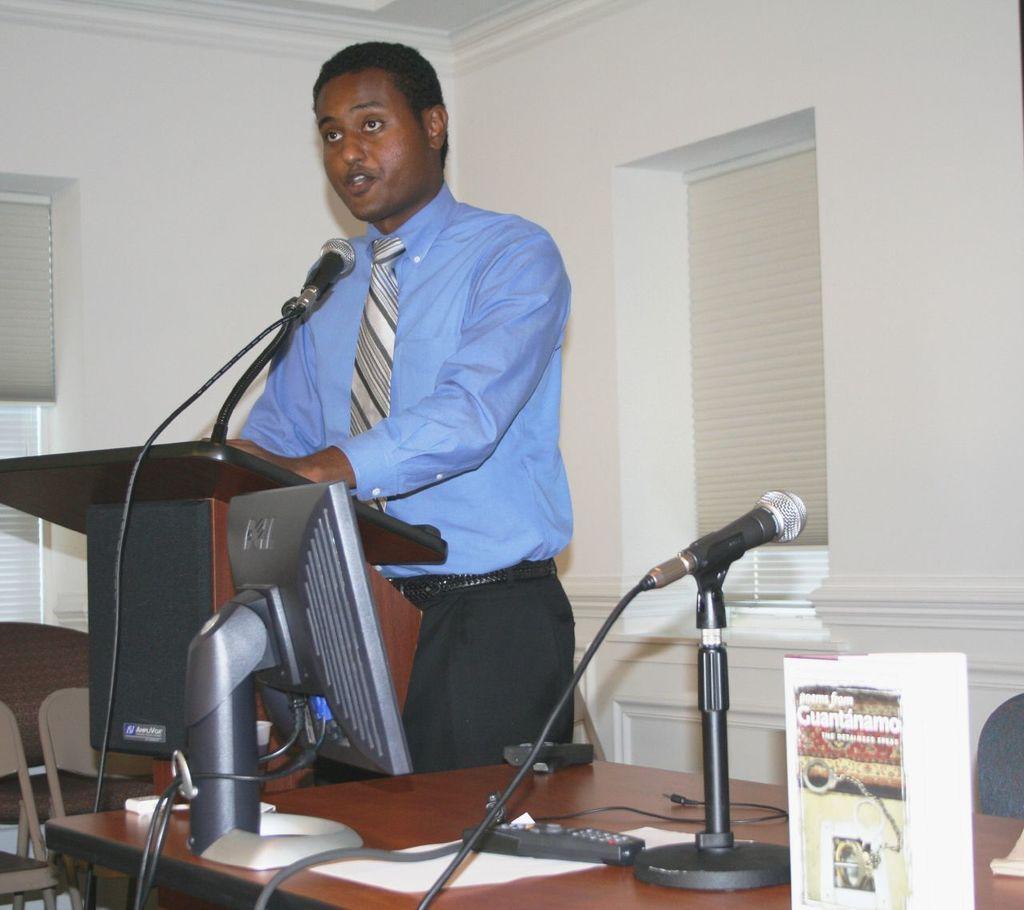Describe this image in one or two sentences. On the table there is a monitor,remote,microphone on a stand and an object. In the background there is a man standing at the podium and talking on a mike and we can also see wall,chairs and windows. 